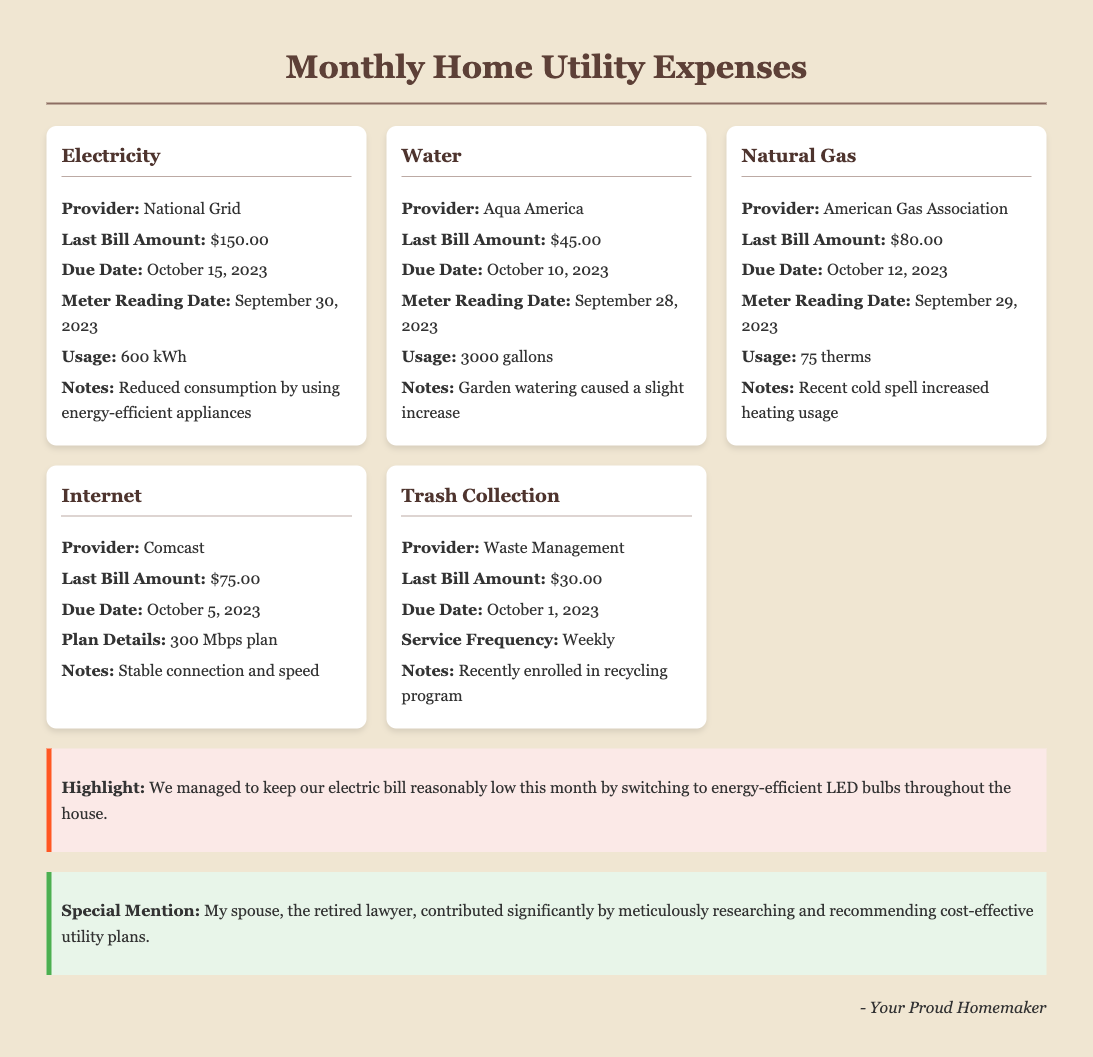What is the last bill amount for electricity? The last bill amount for electricity is listed in the document under the Electricity section, which states $150.00.
Answer: $150.00 When is the due date for the water bill? The due date for the water bill can be found in the Water section of the document, which shows October 10, 2023.
Answer: October 10, 2023 What was the usage for natural gas in therms? The document specifies the usage for natural gas in the Natural Gas section, which is 75 therms.
Answer: 75 therms Which provider manages the internet service? The internet service provider is mentioned in the Internet section, which is Comcast.
Answer: Comcast What special mention is made about the retired lawyer? The document highlights a special mention for the retired lawyer, stating they contributed significantly by researching and recommending cost-effective utility plans.
Answer: Contributed significantly by meticulously researching and recommending cost-effective utility plans How much total was spent on all utility bills? The total expense can be calculated by adding all the last bill amounts listed for each utility: $150.00 + $45.00 + $80.00 + $75.00 + $30.00 = $380.00.
Answer: $380.00 